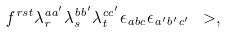<formula> <loc_0><loc_0><loc_500><loc_500>f ^ { r s t } \lambda _ { r } ^ { a a ^ { \prime } } \lambda _ { s } ^ { b b ^ { \prime } } \lambda _ { t } ^ { c c ^ { \prime } } \epsilon _ { a b c } \epsilon _ { a ^ { \prime } b ^ { \prime } c ^ { \prime } } \ > ,</formula> 